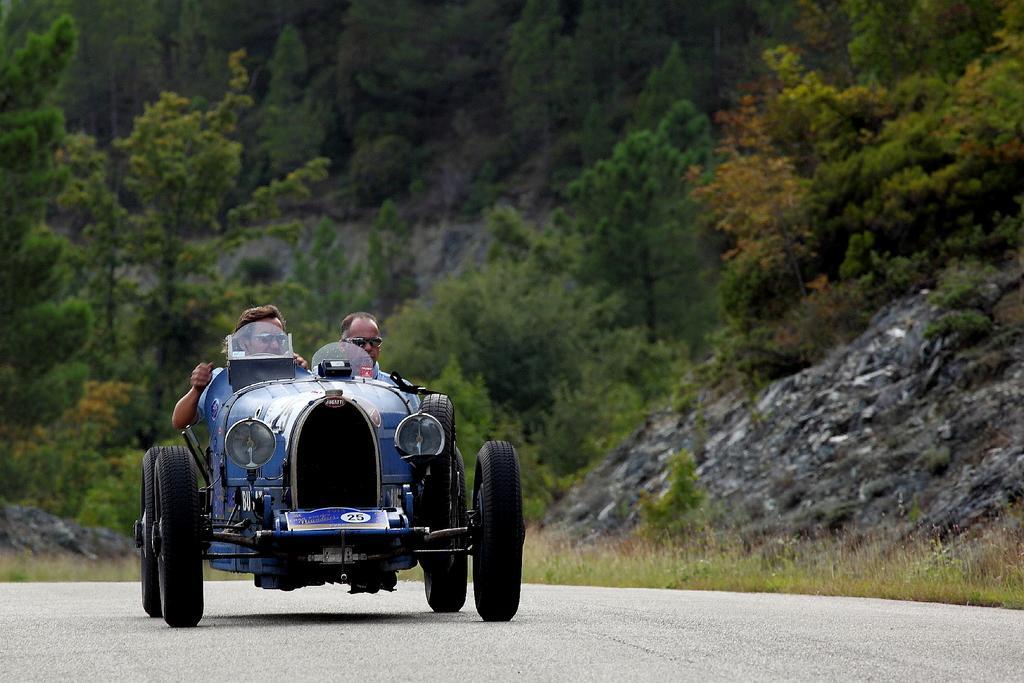Please provide a concise description of this image. There is a road. On the road there is a vehicle. Two people wearing goggles is sitting on the vehicle. On the side there is rock. In the background there are trees. 